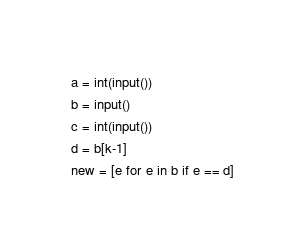<code> <loc_0><loc_0><loc_500><loc_500><_Python_>a = int(input())
b = input()
c = int(input())
d = b[k-1]
new = [e for e in b if e == d]</code> 